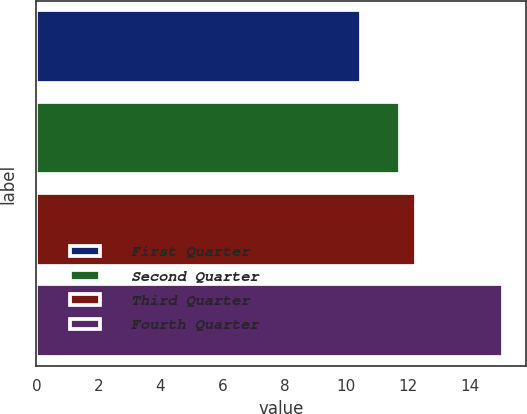Convert chart. <chart><loc_0><loc_0><loc_500><loc_500><bar_chart><fcel>First Quarter<fcel>Second Quarter<fcel>Third Quarter<fcel>Fourth Quarter<nl><fcel>10.46<fcel>11.73<fcel>12.25<fcel>15.05<nl></chart> 